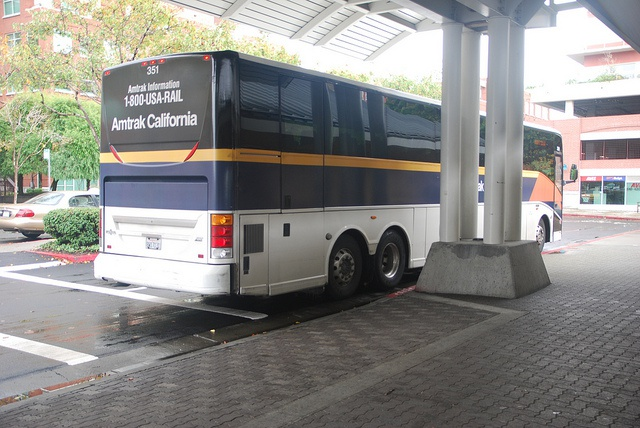Describe the objects in this image and their specific colors. I can see bus in lightpink, gray, black, white, and darkgray tones and car in lightpink, white, darkgray, gray, and pink tones in this image. 